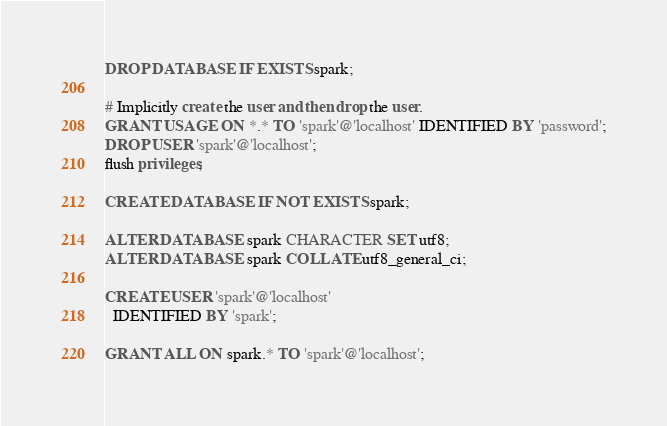<code> <loc_0><loc_0><loc_500><loc_500><_SQL_>DROP DATABASE IF EXISTS spark;

# Implicitly create the user and then drop the user.
GRANT USAGE ON *.* TO 'spark'@'localhost' IDENTIFIED BY 'password';
DROP USER 'spark'@'localhost';
flush privileges;

CREATE DATABASE IF NOT EXISTS spark;

ALTER DATABASE spark CHARACTER SET utf8;
ALTER DATABASE spark COLLATE utf8_general_ci;

CREATE USER 'spark'@'localhost'
  IDENTIFIED BY 'spark';

GRANT ALL ON spark.* TO 'spark'@'localhost';
</code> 